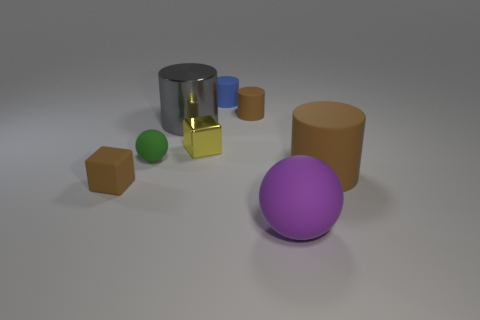Add 2 tiny green matte blocks. How many objects exist? 10 Subtract all brown balls. How many brown cylinders are left? 2 Subtract all large brown cylinders. How many cylinders are left? 3 Subtract all blue cylinders. How many cylinders are left? 3 Add 4 tiny red things. How many tiny red things exist? 4 Subtract 1 yellow blocks. How many objects are left? 7 Subtract all blocks. How many objects are left? 6 Subtract all red cylinders. Subtract all red cubes. How many cylinders are left? 4 Subtract all red matte things. Subtract all green rubber objects. How many objects are left? 7 Add 1 big matte cylinders. How many big matte cylinders are left? 2 